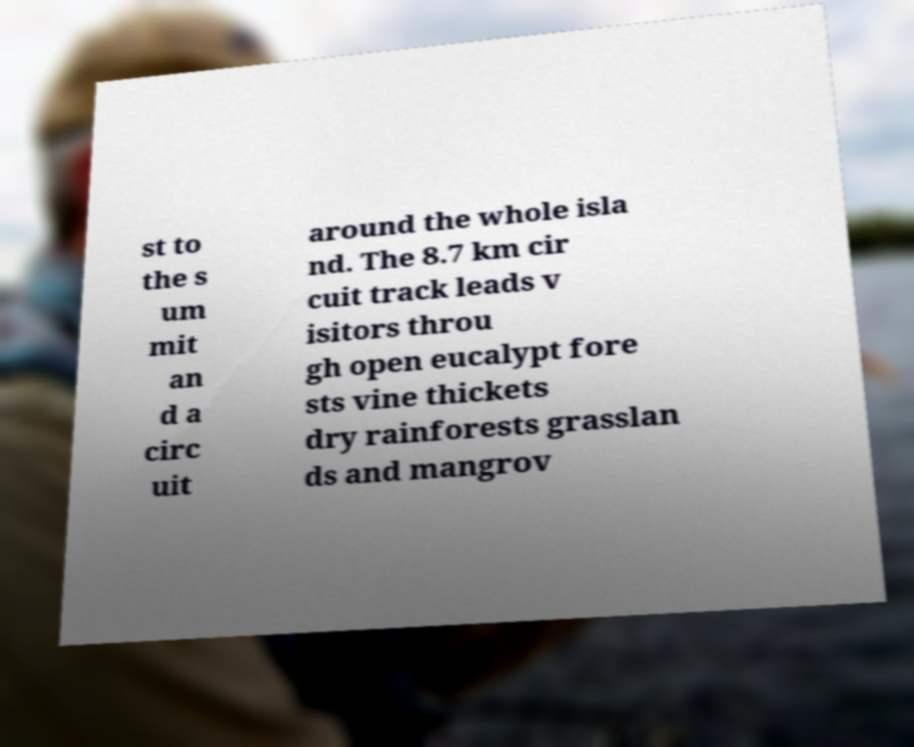Please identify and transcribe the text found in this image. st to the s um mit an d a circ uit around the whole isla nd. The 8.7 km cir cuit track leads v isitors throu gh open eucalypt fore sts vine thickets dry rainforests grasslan ds and mangrov 